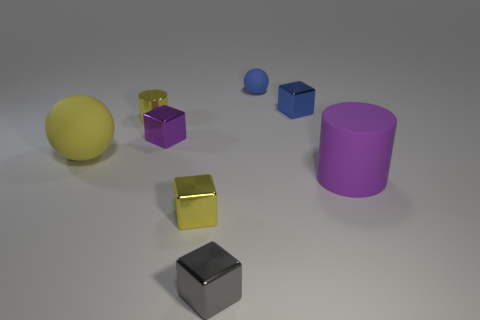How many yellow cubes are in front of the cylinder that is right of the yellow metal object behind the large yellow object?
Provide a short and direct response. 1. Is the number of large balls less than the number of green balls?
Make the answer very short. No. There is a big thing that is right of the small purple shiny object; is it the same shape as the purple object behind the large yellow matte sphere?
Ensure brevity in your answer.  No. What color is the large cylinder?
Your answer should be compact. Purple. How many metallic things are either gray objects or tiny spheres?
Offer a very short reply. 1. There is another matte thing that is the same shape as the big yellow object; what color is it?
Your answer should be compact. Blue. Are any green matte cylinders visible?
Make the answer very short. No. Are the tiny cube right of the gray metal block and the big object that is to the left of the big cylinder made of the same material?
Ensure brevity in your answer.  No. What is the shape of the large matte thing that is the same color as the small cylinder?
Your answer should be compact. Sphere. How many objects are yellow metal things behind the tiny yellow block or rubber things that are in front of the small blue block?
Your answer should be very brief. 3. 